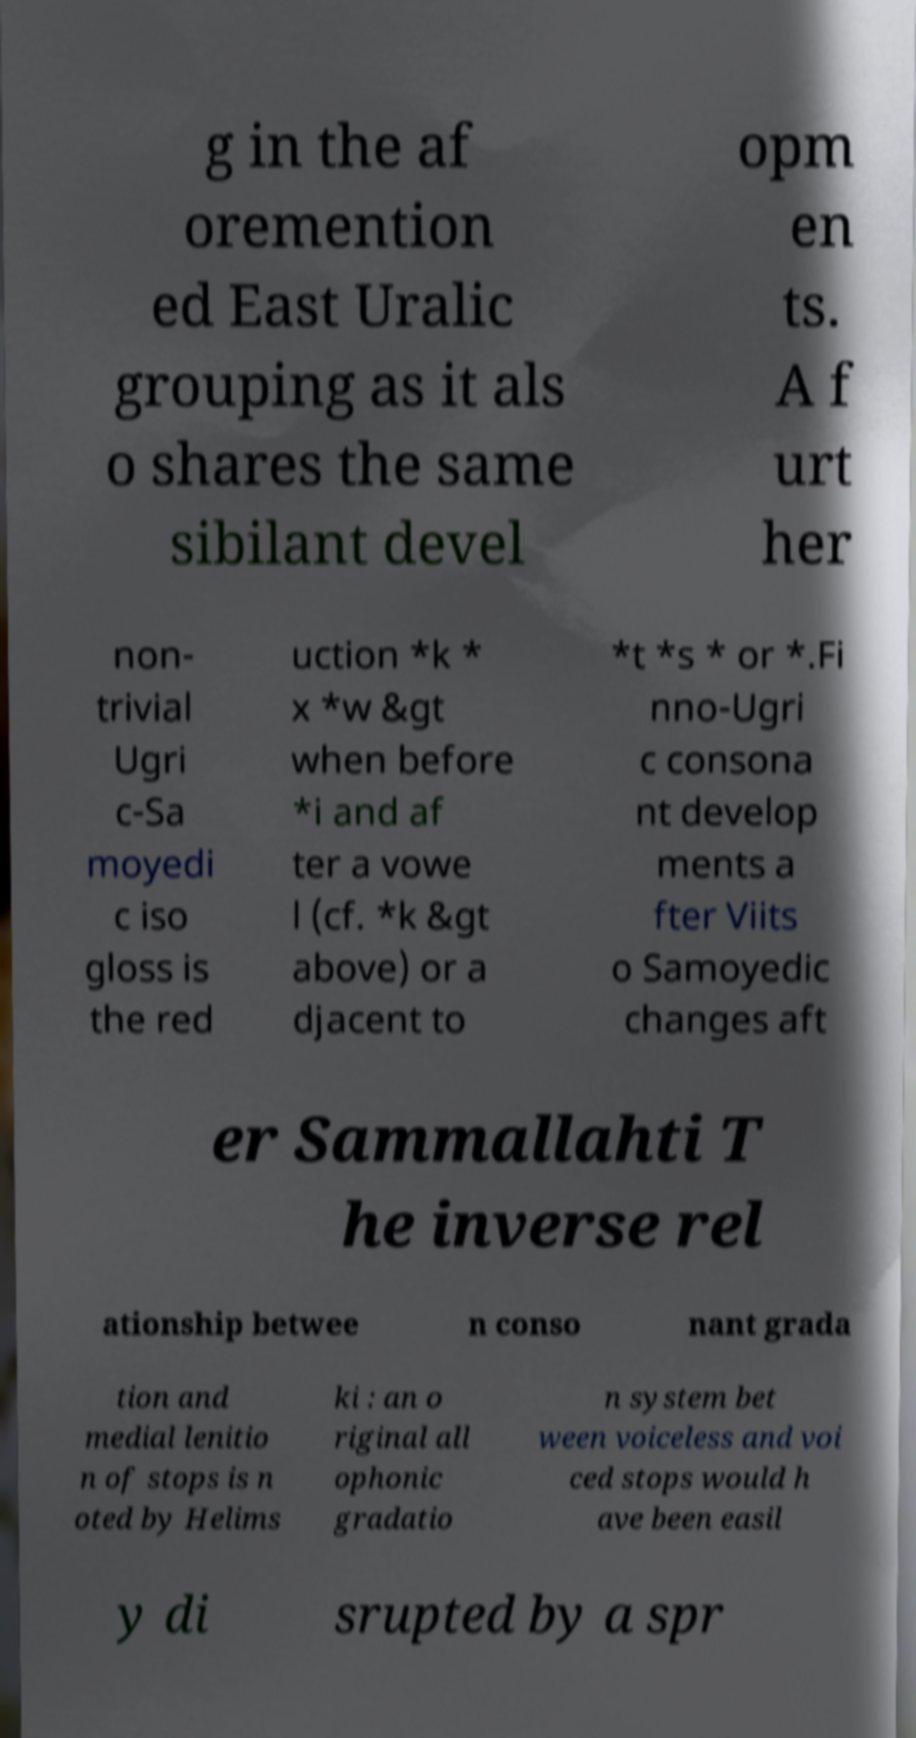Please read and relay the text visible in this image. What does it say? g in the af oremention ed East Uralic grouping as it als o shares the same sibilant devel opm en ts. A f urt her non- trivial Ugri c-Sa moyedi c iso gloss is the red uction *k * x *w &gt when before *i and af ter a vowe l (cf. *k &gt above) or a djacent to *t *s * or *.Fi nno-Ugri c consona nt develop ments a fter Viits o Samoyedic changes aft er Sammallahti T he inverse rel ationship betwee n conso nant grada tion and medial lenitio n of stops is n oted by Helims ki : an o riginal all ophonic gradatio n system bet ween voiceless and voi ced stops would h ave been easil y di srupted by a spr 